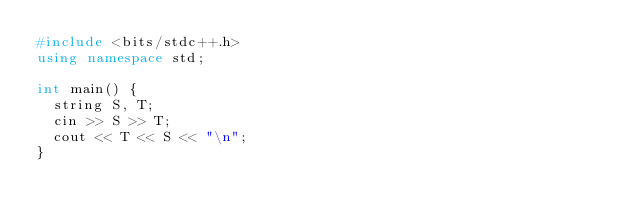<code> <loc_0><loc_0><loc_500><loc_500><_C++_>#include <bits/stdc++.h>
using namespace std;

int main() {
  string S, T;
  cin >> S >> T;
  cout << T << S << "\n";
}</code> 